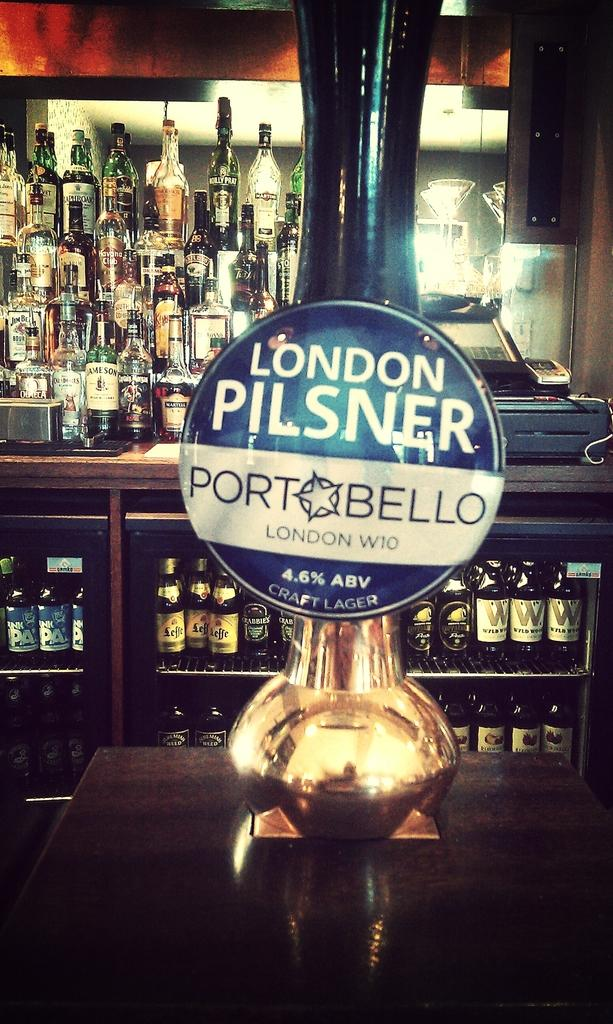<image>
Give a short and clear explanation of the subsequent image. A bar tap machine with the logo London Pilsner PortBello on it 